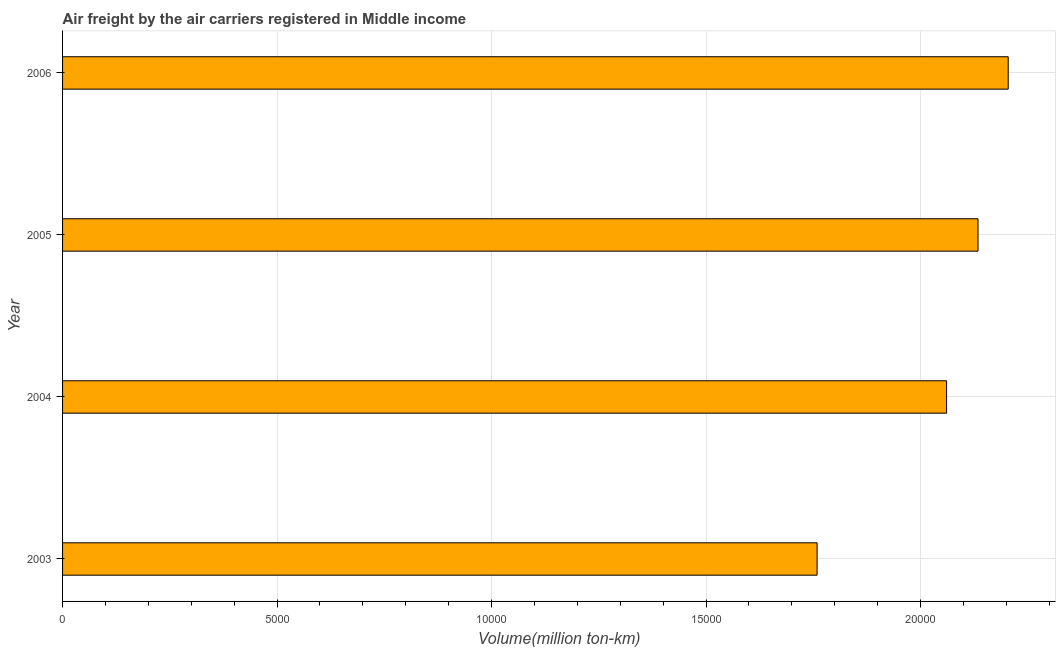What is the title of the graph?
Provide a succinct answer. Air freight by the air carriers registered in Middle income. What is the label or title of the X-axis?
Your response must be concise. Volume(million ton-km). What is the label or title of the Y-axis?
Provide a succinct answer. Year. What is the air freight in 2005?
Offer a terse response. 2.13e+04. Across all years, what is the maximum air freight?
Make the answer very short. 2.20e+04. Across all years, what is the minimum air freight?
Your answer should be very brief. 1.76e+04. In which year was the air freight maximum?
Your response must be concise. 2006. In which year was the air freight minimum?
Give a very brief answer. 2003. What is the sum of the air freight?
Give a very brief answer. 8.16e+04. What is the difference between the air freight in 2003 and 2005?
Provide a short and direct response. -3751.68. What is the average air freight per year?
Make the answer very short. 2.04e+04. What is the median air freight?
Keep it short and to the point. 2.10e+04. In how many years, is the air freight greater than 6000 million ton-km?
Ensure brevity in your answer.  4. Do a majority of the years between 2003 and 2004 (inclusive) have air freight greater than 16000 million ton-km?
Provide a short and direct response. Yes. What is the ratio of the air freight in 2004 to that in 2005?
Keep it short and to the point. 0.97. What is the difference between the highest and the second highest air freight?
Provide a succinct answer. 703.79. Is the sum of the air freight in 2003 and 2006 greater than the maximum air freight across all years?
Provide a short and direct response. Yes. What is the difference between the highest and the lowest air freight?
Give a very brief answer. 4455.47. Are all the bars in the graph horizontal?
Keep it short and to the point. Yes. How many years are there in the graph?
Offer a terse response. 4. What is the Volume(million ton-km) of 2003?
Give a very brief answer. 1.76e+04. What is the Volume(million ton-km) in 2004?
Your response must be concise. 2.06e+04. What is the Volume(million ton-km) of 2005?
Your answer should be very brief. 2.13e+04. What is the Volume(million ton-km) in 2006?
Ensure brevity in your answer.  2.20e+04. What is the difference between the Volume(million ton-km) in 2003 and 2004?
Make the answer very short. -3019.23. What is the difference between the Volume(million ton-km) in 2003 and 2005?
Keep it short and to the point. -3751.68. What is the difference between the Volume(million ton-km) in 2003 and 2006?
Give a very brief answer. -4455.47. What is the difference between the Volume(million ton-km) in 2004 and 2005?
Your answer should be very brief. -732.44. What is the difference between the Volume(million ton-km) in 2004 and 2006?
Give a very brief answer. -1436.24. What is the difference between the Volume(million ton-km) in 2005 and 2006?
Offer a terse response. -703.79. What is the ratio of the Volume(million ton-km) in 2003 to that in 2004?
Make the answer very short. 0.85. What is the ratio of the Volume(million ton-km) in 2003 to that in 2005?
Ensure brevity in your answer.  0.82. What is the ratio of the Volume(million ton-km) in 2003 to that in 2006?
Make the answer very short. 0.8. What is the ratio of the Volume(million ton-km) in 2004 to that in 2006?
Offer a very short reply. 0.94. What is the ratio of the Volume(million ton-km) in 2005 to that in 2006?
Your answer should be very brief. 0.97. 